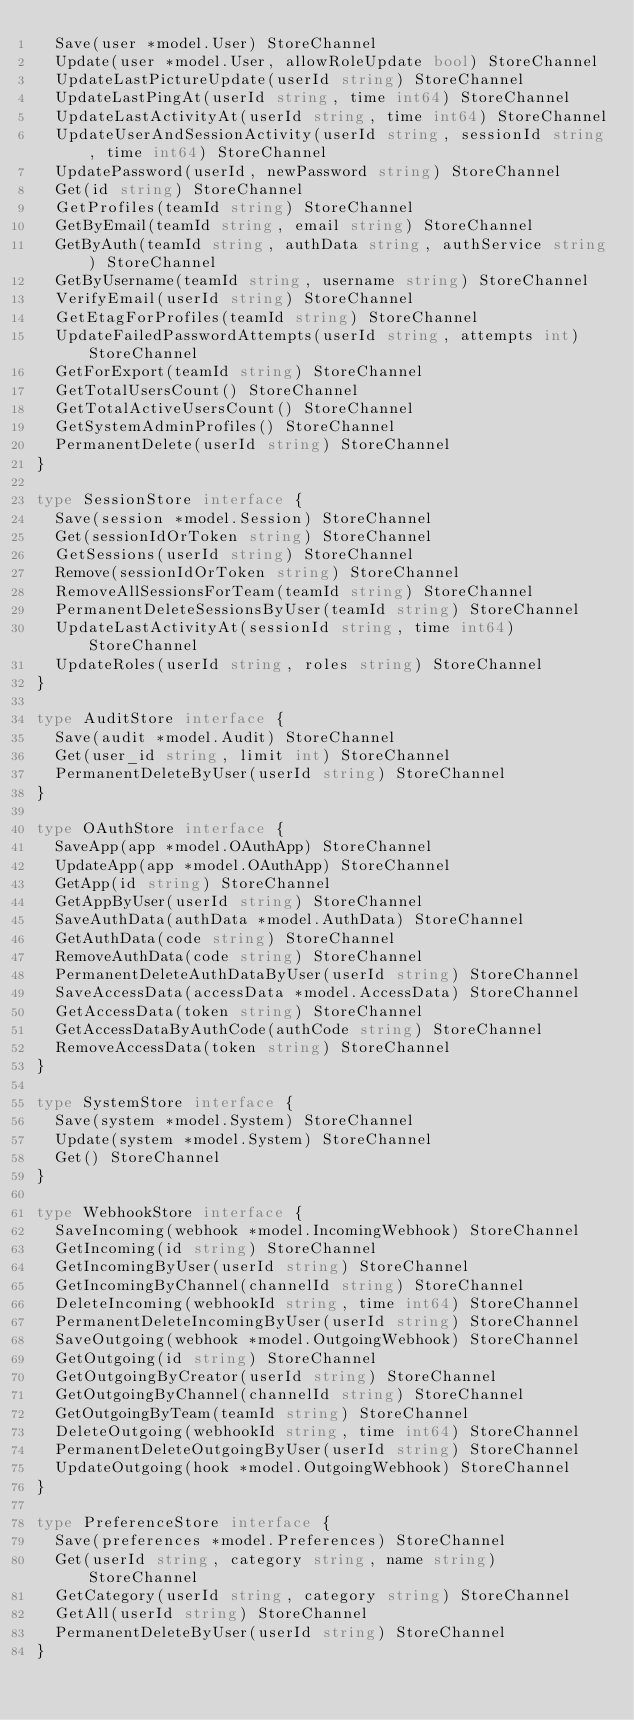<code> <loc_0><loc_0><loc_500><loc_500><_Go_>	Save(user *model.User) StoreChannel
	Update(user *model.User, allowRoleUpdate bool) StoreChannel
	UpdateLastPictureUpdate(userId string) StoreChannel
	UpdateLastPingAt(userId string, time int64) StoreChannel
	UpdateLastActivityAt(userId string, time int64) StoreChannel
	UpdateUserAndSessionActivity(userId string, sessionId string, time int64) StoreChannel
	UpdatePassword(userId, newPassword string) StoreChannel
	Get(id string) StoreChannel
	GetProfiles(teamId string) StoreChannel
	GetByEmail(teamId string, email string) StoreChannel
	GetByAuth(teamId string, authData string, authService string) StoreChannel
	GetByUsername(teamId string, username string) StoreChannel
	VerifyEmail(userId string) StoreChannel
	GetEtagForProfiles(teamId string) StoreChannel
	UpdateFailedPasswordAttempts(userId string, attempts int) StoreChannel
	GetForExport(teamId string) StoreChannel
	GetTotalUsersCount() StoreChannel
	GetTotalActiveUsersCount() StoreChannel
	GetSystemAdminProfiles() StoreChannel
	PermanentDelete(userId string) StoreChannel
}

type SessionStore interface {
	Save(session *model.Session) StoreChannel
	Get(sessionIdOrToken string) StoreChannel
	GetSessions(userId string) StoreChannel
	Remove(sessionIdOrToken string) StoreChannel
	RemoveAllSessionsForTeam(teamId string) StoreChannel
	PermanentDeleteSessionsByUser(teamId string) StoreChannel
	UpdateLastActivityAt(sessionId string, time int64) StoreChannel
	UpdateRoles(userId string, roles string) StoreChannel
}

type AuditStore interface {
	Save(audit *model.Audit) StoreChannel
	Get(user_id string, limit int) StoreChannel
	PermanentDeleteByUser(userId string) StoreChannel
}

type OAuthStore interface {
	SaveApp(app *model.OAuthApp) StoreChannel
	UpdateApp(app *model.OAuthApp) StoreChannel
	GetApp(id string) StoreChannel
	GetAppByUser(userId string) StoreChannel
	SaveAuthData(authData *model.AuthData) StoreChannel
	GetAuthData(code string) StoreChannel
	RemoveAuthData(code string) StoreChannel
	PermanentDeleteAuthDataByUser(userId string) StoreChannel
	SaveAccessData(accessData *model.AccessData) StoreChannel
	GetAccessData(token string) StoreChannel
	GetAccessDataByAuthCode(authCode string) StoreChannel
	RemoveAccessData(token string) StoreChannel
}

type SystemStore interface {
	Save(system *model.System) StoreChannel
	Update(system *model.System) StoreChannel
	Get() StoreChannel
}

type WebhookStore interface {
	SaveIncoming(webhook *model.IncomingWebhook) StoreChannel
	GetIncoming(id string) StoreChannel
	GetIncomingByUser(userId string) StoreChannel
	GetIncomingByChannel(channelId string) StoreChannel
	DeleteIncoming(webhookId string, time int64) StoreChannel
	PermanentDeleteIncomingByUser(userId string) StoreChannel
	SaveOutgoing(webhook *model.OutgoingWebhook) StoreChannel
	GetOutgoing(id string) StoreChannel
	GetOutgoingByCreator(userId string) StoreChannel
	GetOutgoingByChannel(channelId string) StoreChannel
	GetOutgoingByTeam(teamId string) StoreChannel
	DeleteOutgoing(webhookId string, time int64) StoreChannel
	PermanentDeleteOutgoingByUser(userId string) StoreChannel
	UpdateOutgoing(hook *model.OutgoingWebhook) StoreChannel
}

type PreferenceStore interface {
	Save(preferences *model.Preferences) StoreChannel
	Get(userId string, category string, name string) StoreChannel
	GetCategory(userId string, category string) StoreChannel
	GetAll(userId string) StoreChannel
	PermanentDeleteByUser(userId string) StoreChannel
}
</code> 